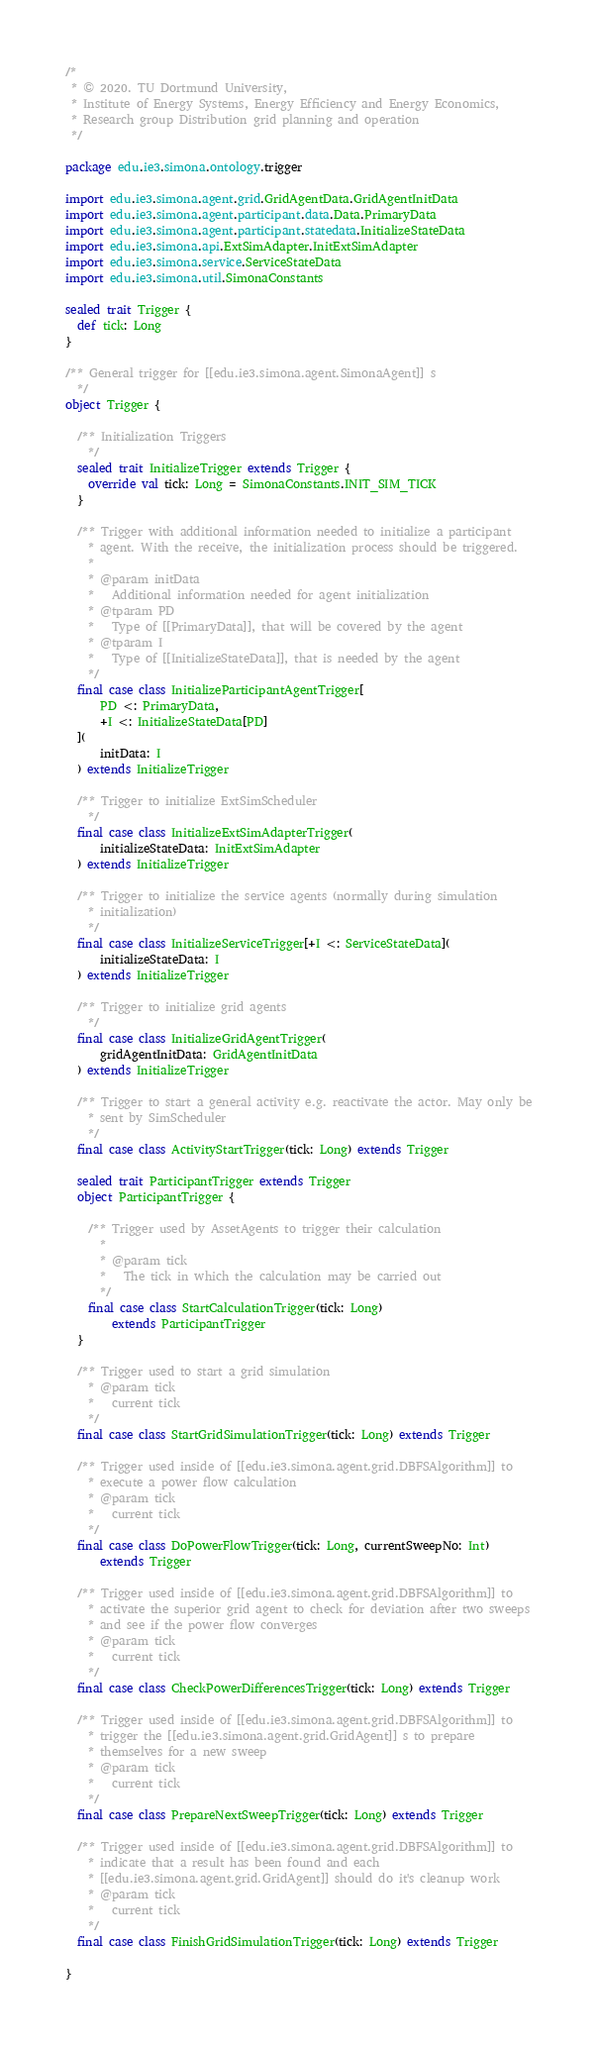Convert code to text. <code><loc_0><loc_0><loc_500><loc_500><_Scala_>/*
 * © 2020. TU Dortmund University,
 * Institute of Energy Systems, Energy Efficiency and Energy Economics,
 * Research group Distribution grid planning and operation
 */

package edu.ie3.simona.ontology.trigger

import edu.ie3.simona.agent.grid.GridAgentData.GridAgentInitData
import edu.ie3.simona.agent.participant.data.Data.PrimaryData
import edu.ie3.simona.agent.participant.statedata.InitializeStateData
import edu.ie3.simona.api.ExtSimAdapter.InitExtSimAdapter
import edu.ie3.simona.service.ServiceStateData
import edu.ie3.simona.util.SimonaConstants

sealed trait Trigger {
  def tick: Long
}

/** General trigger for [[edu.ie3.simona.agent.SimonaAgent]] s
  */
object Trigger {

  /** Initialization Triggers
    */
  sealed trait InitializeTrigger extends Trigger {
    override val tick: Long = SimonaConstants.INIT_SIM_TICK
  }

  /** Trigger with additional information needed to initialize a participant
    * agent. With the receive, the initialization process should be triggered.
    *
    * @param initData
    *   Additional information needed for agent initialization
    * @tparam PD
    *   Type of [[PrimaryData]], that will be covered by the agent
    * @tparam I
    *   Type of [[InitializeStateData]], that is needed by the agent
    */
  final case class InitializeParticipantAgentTrigger[
      PD <: PrimaryData,
      +I <: InitializeStateData[PD]
  ](
      initData: I
  ) extends InitializeTrigger

  /** Trigger to initialize ExtSimScheduler
    */
  final case class InitializeExtSimAdapterTrigger(
      initializeStateData: InitExtSimAdapter
  ) extends InitializeTrigger

  /** Trigger to initialize the service agents (normally during simulation
    * initialization)
    */
  final case class InitializeServiceTrigger[+I <: ServiceStateData](
      initializeStateData: I
  ) extends InitializeTrigger

  /** Trigger to initialize grid agents
    */
  final case class InitializeGridAgentTrigger(
      gridAgentInitData: GridAgentInitData
  ) extends InitializeTrigger

  /** Trigger to start a general activity e.g. reactivate the actor. May only be
    * sent by SimScheduler
    */
  final case class ActivityStartTrigger(tick: Long) extends Trigger

  sealed trait ParticipantTrigger extends Trigger
  object ParticipantTrigger {

    /** Trigger used by AssetAgents to trigger their calculation
      *
      * @param tick
      *   The tick in which the calculation may be carried out
      */
    final case class StartCalculationTrigger(tick: Long)
        extends ParticipantTrigger
  }

  /** Trigger used to start a grid simulation
    * @param tick
    *   current tick
    */
  final case class StartGridSimulationTrigger(tick: Long) extends Trigger

  /** Trigger used inside of [[edu.ie3.simona.agent.grid.DBFSAlgorithm]] to
    * execute a power flow calculation
    * @param tick
    *   current tick
    */
  final case class DoPowerFlowTrigger(tick: Long, currentSweepNo: Int)
      extends Trigger

  /** Trigger used inside of [[edu.ie3.simona.agent.grid.DBFSAlgorithm]] to
    * activate the superior grid agent to check for deviation after two sweeps
    * and see if the power flow converges
    * @param tick
    *   current tick
    */
  final case class CheckPowerDifferencesTrigger(tick: Long) extends Trigger

  /** Trigger used inside of [[edu.ie3.simona.agent.grid.DBFSAlgorithm]] to
    * trigger the [[edu.ie3.simona.agent.grid.GridAgent]] s to prepare
    * themselves for a new sweep
    * @param tick
    *   current tick
    */
  final case class PrepareNextSweepTrigger(tick: Long) extends Trigger

  /** Trigger used inside of [[edu.ie3.simona.agent.grid.DBFSAlgorithm]] to
    * indicate that a result has been found and each
    * [[edu.ie3.simona.agent.grid.GridAgent]] should do it's cleanup work
    * @param tick
    *   current tick
    */
  final case class FinishGridSimulationTrigger(tick: Long) extends Trigger

}
</code> 